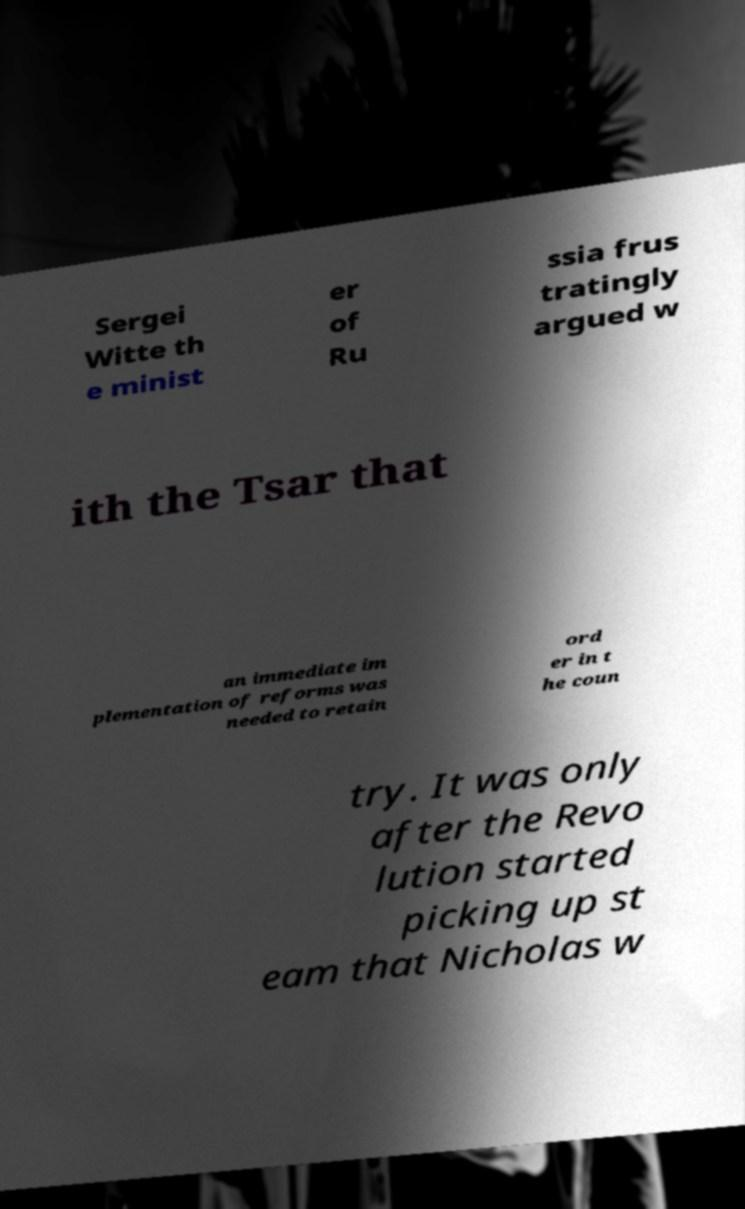Could you assist in decoding the text presented in this image and type it out clearly? Sergei Witte th e minist er of Ru ssia frus tratingly argued w ith the Tsar that an immediate im plementation of reforms was needed to retain ord er in t he coun try. It was only after the Revo lution started picking up st eam that Nicholas w 